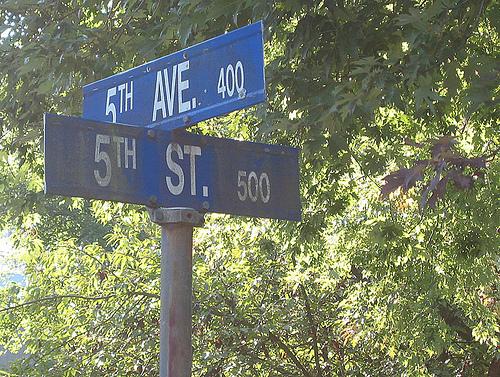What Avenue is shown?
Concise answer only. 5th. What is in the background of the photo?
Be succinct. Trees. What number do the signs have in common?
Quick response, please. 5. 